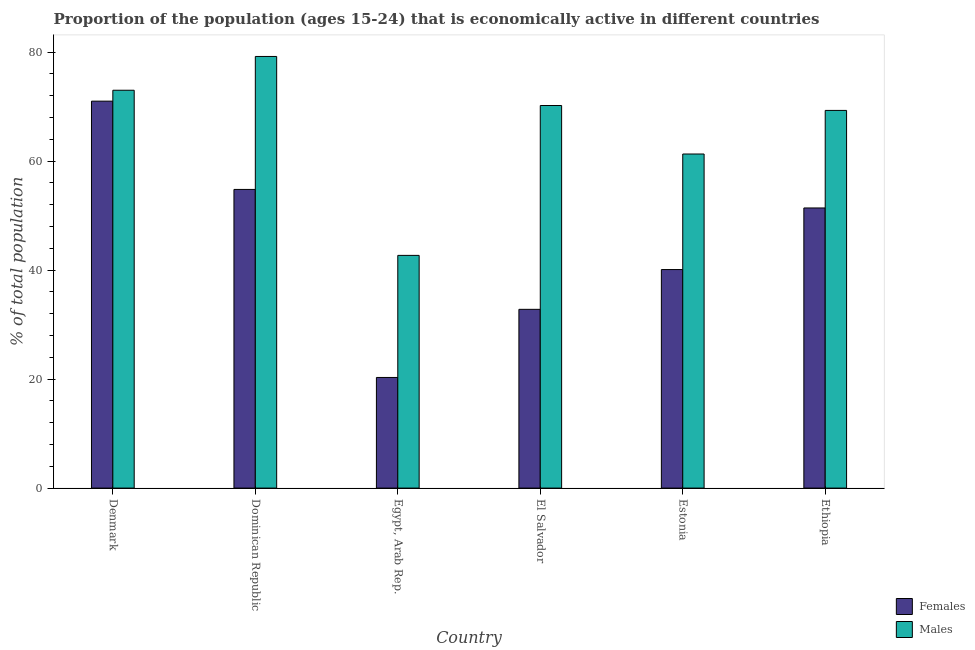How many groups of bars are there?
Your answer should be very brief. 6. Are the number of bars on each tick of the X-axis equal?
Offer a terse response. Yes. How many bars are there on the 3rd tick from the left?
Ensure brevity in your answer.  2. How many bars are there on the 4th tick from the right?
Make the answer very short. 2. What is the label of the 3rd group of bars from the left?
Provide a short and direct response. Egypt, Arab Rep. In how many cases, is the number of bars for a given country not equal to the number of legend labels?
Provide a succinct answer. 0. What is the percentage of economically active female population in Egypt, Arab Rep.?
Make the answer very short. 20.3. Across all countries, what is the maximum percentage of economically active female population?
Ensure brevity in your answer.  71. Across all countries, what is the minimum percentage of economically active female population?
Ensure brevity in your answer.  20.3. In which country was the percentage of economically active male population maximum?
Provide a short and direct response. Dominican Republic. In which country was the percentage of economically active male population minimum?
Your response must be concise. Egypt, Arab Rep. What is the total percentage of economically active female population in the graph?
Offer a very short reply. 270.4. What is the difference between the percentage of economically active female population in Dominican Republic and that in Ethiopia?
Provide a short and direct response. 3.4. What is the difference between the percentage of economically active male population in Denmark and the percentage of economically active female population in El Salvador?
Provide a succinct answer. 40.2. What is the average percentage of economically active female population per country?
Your answer should be compact. 45.07. What is the difference between the percentage of economically active male population and percentage of economically active female population in Egypt, Arab Rep.?
Make the answer very short. 22.4. What is the ratio of the percentage of economically active female population in Denmark to that in Ethiopia?
Make the answer very short. 1.38. What is the difference between the highest and the second highest percentage of economically active male population?
Make the answer very short. 6.2. What is the difference between the highest and the lowest percentage of economically active female population?
Your answer should be compact. 50.7. What does the 2nd bar from the left in Egypt, Arab Rep. represents?
Offer a terse response. Males. What does the 2nd bar from the right in Estonia represents?
Your response must be concise. Females. How many bars are there?
Ensure brevity in your answer.  12. Are all the bars in the graph horizontal?
Offer a terse response. No. Are the values on the major ticks of Y-axis written in scientific E-notation?
Provide a short and direct response. No. Does the graph contain any zero values?
Your response must be concise. No. How many legend labels are there?
Your response must be concise. 2. What is the title of the graph?
Ensure brevity in your answer.  Proportion of the population (ages 15-24) that is economically active in different countries. What is the label or title of the Y-axis?
Keep it short and to the point. % of total population. What is the % of total population in Females in Denmark?
Keep it short and to the point. 71. What is the % of total population of Females in Dominican Republic?
Offer a terse response. 54.8. What is the % of total population of Males in Dominican Republic?
Offer a very short reply. 79.2. What is the % of total population of Females in Egypt, Arab Rep.?
Provide a short and direct response. 20.3. What is the % of total population of Males in Egypt, Arab Rep.?
Your answer should be compact. 42.7. What is the % of total population in Females in El Salvador?
Your answer should be very brief. 32.8. What is the % of total population of Males in El Salvador?
Offer a very short reply. 70.2. What is the % of total population in Females in Estonia?
Your answer should be very brief. 40.1. What is the % of total population of Males in Estonia?
Offer a very short reply. 61.3. What is the % of total population of Females in Ethiopia?
Ensure brevity in your answer.  51.4. What is the % of total population of Males in Ethiopia?
Provide a succinct answer. 69.3. Across all countries, what is the maximum % of total population of Males?
Provide a succinct answer. 79.2. Across all countries, what is the minimum % of total population in Females?
Your answer should be compact. 20.3. Across all countries, what is the minimum % of total population of Males?
Your answer should be compact. 42.7. What is the total % of total population in Females in the graph?
Offer a terse response. 270.4. What is the total % of total population of Males in the graph?
Ensure brevity in your answer.  395.7. What is the difference between the % of total population of Females in Denmark and that in Dominican Republic?
Provide a short and direct response. 16.2. What is the difference between the % of total population of Males in Denmark and that in Dominican Republic?
Give a very brief answer. -6.2. What is the difference between the % of total population in Females in Denmark and that in Egypt, Arab Rep.?
Your answer should be very brief. 50.7. What is the difference between the % of total population in Males in Denmark and that in Egypt, Arab Rep.?
Make the answer very short. 30.3. What is the difference between the % of total population of Females in Denmark and that in El Salvador?
Your answer should be compact. 38.2. What is the difference between the % of total population in Females in Denmark and that in Estonia?
Your answer should be very brief. 30.9. What is the difference between the % of total population in Females in Denmark and that in Ethiopia?
Offer a terse response. 19.6. What is the difference between the % of total population of Males in Denmark and that in Ethiopia?
Your response must be concise. 3.7. What is the difference between the % of total population in Females in Dominican Republic and that in Egypt, Arab Rep.?
Offer a terse response. 34.5. What is the difference between the % of total population of Males in Dominican Republic and that in Egypt, Arab Rep.?
Your response must be concise. 36.5. What is the difference between the % of total population of Females in Dominican Republic and that in El Salvador?
Keep it short and to the point. 22. What is the difference between the % of total population in Males in Dominican Republic and that in El Salvador?
Your response must be concise. 9. What is the difference between the % of total population in Males in Dominican Republic and that in Ethiopia?
Your response must be concise. 9.9. What is the difference between the % of total population in Males in Egypt, Arab Rep. and that in El Salvador?
Your answer should be very brief. -27.5. What is the difference between the % of total population of Females in Egypt, Arab Rep. and that in Estonia?
Make the answer very short. -19.8. What is the difference between the % of total population of Males in Egypt, Arab Rep. and that in Estonia?
Offer a very short reply. -18.6. What is the difference between the % of total population of Females in Egypt, Arab Rep. and that in Ethiopia?
Provide a succinct answer. -31.1. What is the difference between the % of total population in Males in Egypt, Arab Rep. and that in Ethiopia?
Your answer should be compact. -26.6. What is the difference between the % of total population of Females in El Salvador and that in Estonia?
Your response must be concise. -7.3. What is the difference between the % of total population of Females in El Salvador and that in Ethiopia?
Provide a succinct answer. -18.6. What is the difference between the % of total population of Males in El Salvador and that in Ethiopia?
Your answer should be compact. 0.9. What is the difference between the % of total population in Females in Denmark and the % of total population in Males in Egypt, Arab Rep.?
Give a very brief answer. 28.3. What is the difference between the % of total population in Females in Denmark and the % of total population in Males in El Salvador?
Make the answer very short. 0.8. What is the difference between the % of total population of Females in Denmark and the % of total population of Males in Estonia?
Provide a short and direct response. 9.7. What is the difference between the % of total population of Females in Dominican Republic and the % of total population of Males in Egypt, Arab Rep.?
Your answer should be compact. 12.1. What is the difference between the % of total population in Females in Dominican Republic and the % of total population in Males in El Salvador?
Give a very brief answer. -15.4. What is the difference between the % of total population in Females in Dominican Republic and the % of total population in Males in Estonia?
Keep it short and to the point. -6.5. What is the difference between the % of total population in Females in Egypt, Arab Rep. and the % of total population in Males in El Salvador?
Your response must be concise. -49.9. What is the difference between the % of total population in Females in Egypt, Arab Rep. and the % of total population in Males in Estonia?
Provide a short and direct response. -41. What is the difference between the % of total population in Females in Egypt, Arab Rep. and the % of total population in Males in Ethiopia?
Your answer should be very brief. -49. What is the difference between the % of total population of Females in El Salvador and the % of total population of Males in Estonia?
Make the answer very short. -28.5. What is the difference between the % of total population in Females in El Salvador and the % of total population in Males in Ethiopia?
Provide a short and direct response. -36.5. What is the difference between the % of total population in Females in Estonia and the % of total population in Males in Ethiopia?
Keep it short and to the point. -29.2. What is the average % of total population in Females per country?
Keep it short and to the point. 45.07. What is the average % of total population in Males per country?
Your response must be concise. 65.95. What is the difference between the % of total population in Females and % of total population in Males in Dominican Republic?
Your response must be concise. -24.4. What is the difference between the % of total population of Females and % of total population of Males in Egypt, Arab Rep.?
Provide a short and direct response. -22.4. What is the difference between the % of total population in Females and % of total population in Males in El Salvador?
Keep it short and to the point. -37.4. What is the difference between the % of total population in Females and % of total population in Males in Estonia?
Your answer should be compact. -21.2. What is the difference between the % of total population in Females and % of total population in Males in Ethiopia?
Make the answer very short. -17.9. What is the ratio of the % of total population in Females in Denmark to that in Dominican Republic?
Your response must be concise. 1.3. What is the ratio of the % of total population in Males in Denmark to that in Dominican Republic?
Keep it short and to the point. 0.92. What is the ratio of the % of total population in Females in Denmark to that in Egypt, Arab Rep.?
Your answer should be compact. 3.5. What is the ratio of the % of total population of Males in Denmark to that in Egypt, Arab Rep.?
Your answer should be compact. 1.71. What is the ratio of the % of total population of Females in Denmark to that in El Salvador?
Keep it short and to the point. 2.16. What is the ratio of the % of total population of Males in Denmark to that in El Salvador?
Ensure brevity in your answer.  1.04. What is the ratio of the % of total population of Females in Denmark to that in Estonia?
Make the answer very short. 1.77. What is the ratio of the % of total population in Males in Denmark to that in Estonia?
Ensure brevity in your answer.  1.19. What is the ratio of the % of total population in Females in Denmark to that in Ethiopia?
Provide a succinct answer. 1.38. What is the ratio of the % of total population in Males in Denmark to that in Ethiopia?
Keep it short and to the point. 1.05. What is the ratio of the % of total population in Females in Dominican Republic to that in Egypt, Arab Rep.?
Provide a succinct answer. 2.7. What is the ratio of the % of total population in Males in Dominican Republic to that in Egypt, Arab Rep.?
Provide a short and direct response. 1.85. What is the ratio of the % of total population of Females in Dominican Republic to that in El Salvador?
Keep it short and to the point. 1.67. What is the ratio of the % of total population of Males in Dominican Republic to that in El Salvador?
Your response must be concise. 1.13. What is the ratio of the % of total population of Females in Dominican Republic to that in Estonia?
Offer a very short reply. 1.37. What is the ratio of the % of total population of Males in Dominican Republic to that in Estonia?
Ensure brevity in your answer.  1.29. What is the ratio of the % of total population of Females in Dominican Republic to that in Ethiopia?
Provide a short and direct response. 1.07. What is the ratio of the % of total population of Males in Dominican Republic to that in Ethiopia?
Ensure brevity in your answer.  1.14. What is the ratio of the % of total population in Females in Egypt, Arab Rep. to that in El Salvador?
Offer a terse response. 0.62. What is the ratio of the % of total population of Males in Egypt, Arab Rep. to that in El Salvador?
Give a very brief answer. 0.61. What is the ratio of the % of total population of Females in Egypt, Arab Rep. to that in Estonia?
Your answer should be very brief. 0.51. What is the ratio of the % of total population of Males in Egypt, Arab Rep. to that in Estonia?
Offer a very short reply. 0.7. What is the ratio of the % of total population of Females in Egypt, Arab Rep. to that in Ethiopia?
Offer a terse response. 0.39. What is the ratio of the % of total population in Males in Egypt, Arab Rep. to that in Ethiopia?
Your answer should be very brief. 0.62. What is the ratio of the % of total population of Females in El Salvador to that in Estonia?
Your answer should be compact. 0.82. What is the ratio of the % of total population in Males in El Salvador to that in Estonia?
Your answer should be very brief. 1.15. What is the ratio of the % of total population in Females in El Salvador to that in Ethiopia?
Your answer should be very brief. 0.64. What is the ratio of the % of total population in Females in Estonia to that in Ethiopia?
Make the answer very short. 0.78. What is the ratio of the % of total population in Males in Estonia to that in Ethiopia?
Offer a terse response. 0.88. What is the difference between the highest and the second highest % of total population in Males?
Offer a very short reply. 6.2. What is the difference between the highest and the lowest % of total population of Females?
Ensure brevity in your answer.  50.7. What is the difference between the highest and the lowest % of total population in Males?
Make the answer very short. 36.5. 